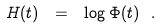<formula> <loc_0><loc_0><loc_500><loc_500>H ( t ) \ = \ \log \Phi ( t ) \ .</formula> 